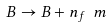<formula> <loc_0><loc_0><loc_500><loc_500>B \rightarrow B + n _ { f } \ m</formula> 